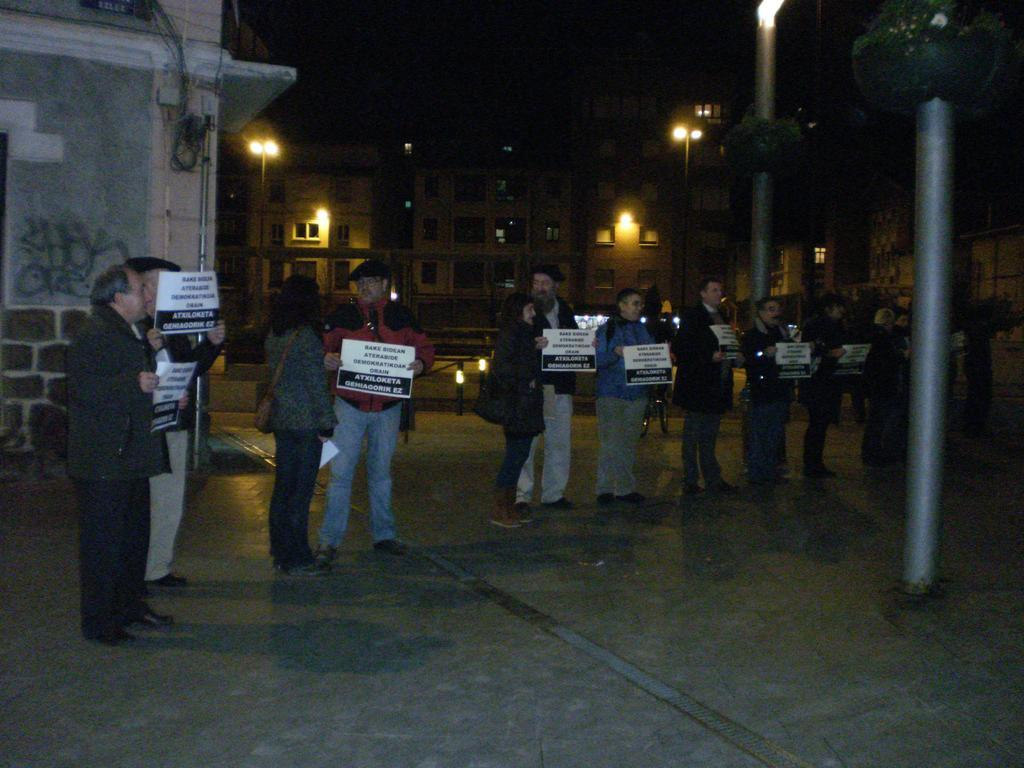What can be seen in the image involving people? There are people standing in the image. What are the people wearing? The people are wearing clothes and shoes. What are the people holding in the image? The people are holding posters. What type of path can be seen in the image? There is a footpath in the image. What structures are present in the image? There are light poles and buildings in the image. How would you describe the sky in the image? The sky is dark in the image. What is the price of the shoes the people are wearing in the image? There is no information about the price of the shoes in the image. What force is being exerted by the people holding the posters in the image? There is no information about any force being exerted by the people holding the posters in the image. 